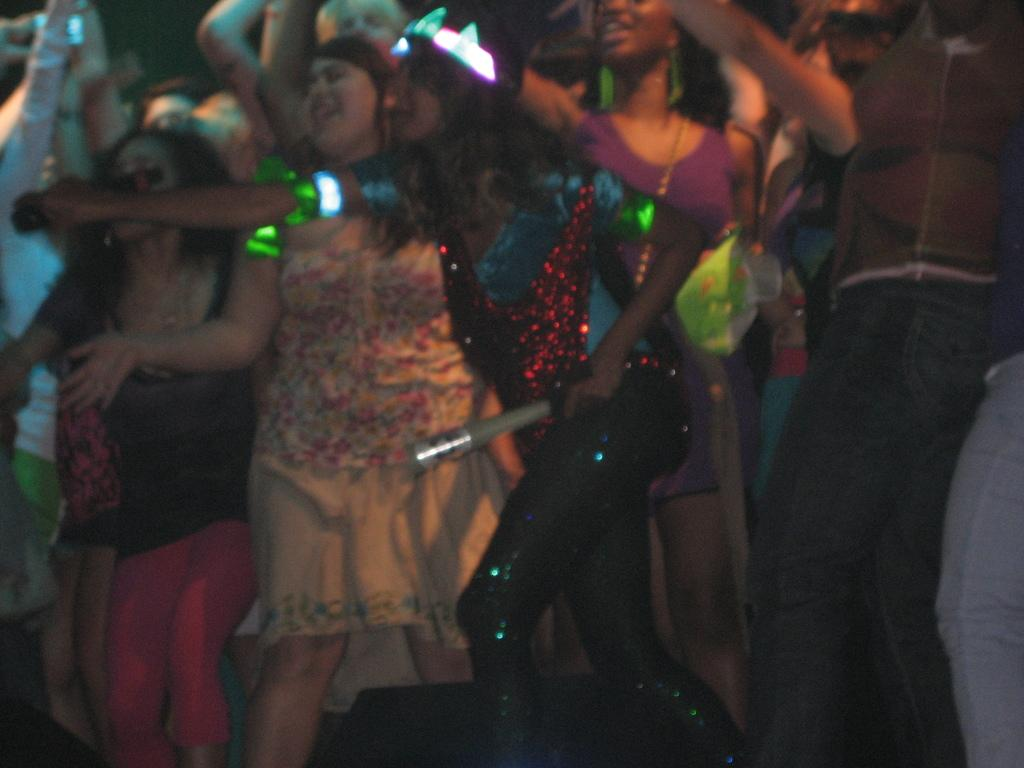Who or what is present in the image? There are people in the image. Where are the people located in the image? The people are in the center of the image. What are the people doing in the image? The people are dancing. What type of toy can be seen at the end of the image? There is no toy present in the image, and the image does not have an end as it is a still photograph. 